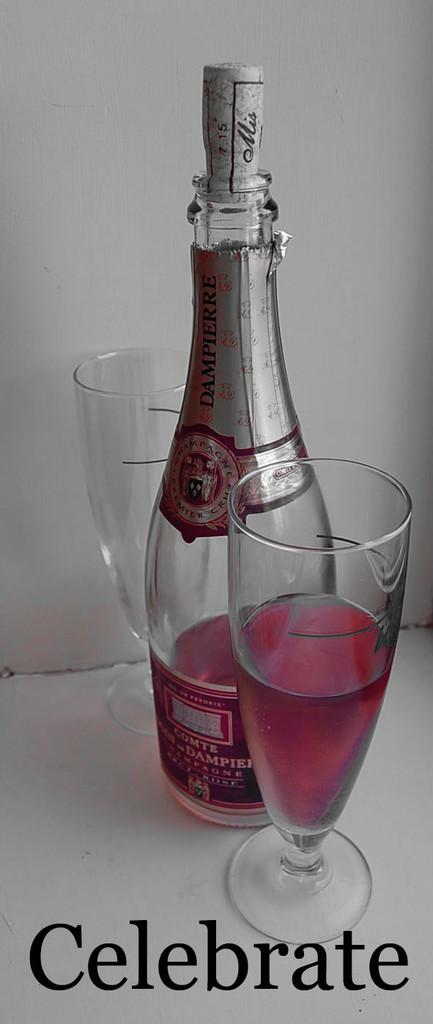Provide a one-sentence caption for the provided image. A BOTTLE OF PINK COMTE CHAMPAGNE AND HALF FULL GLASS. 